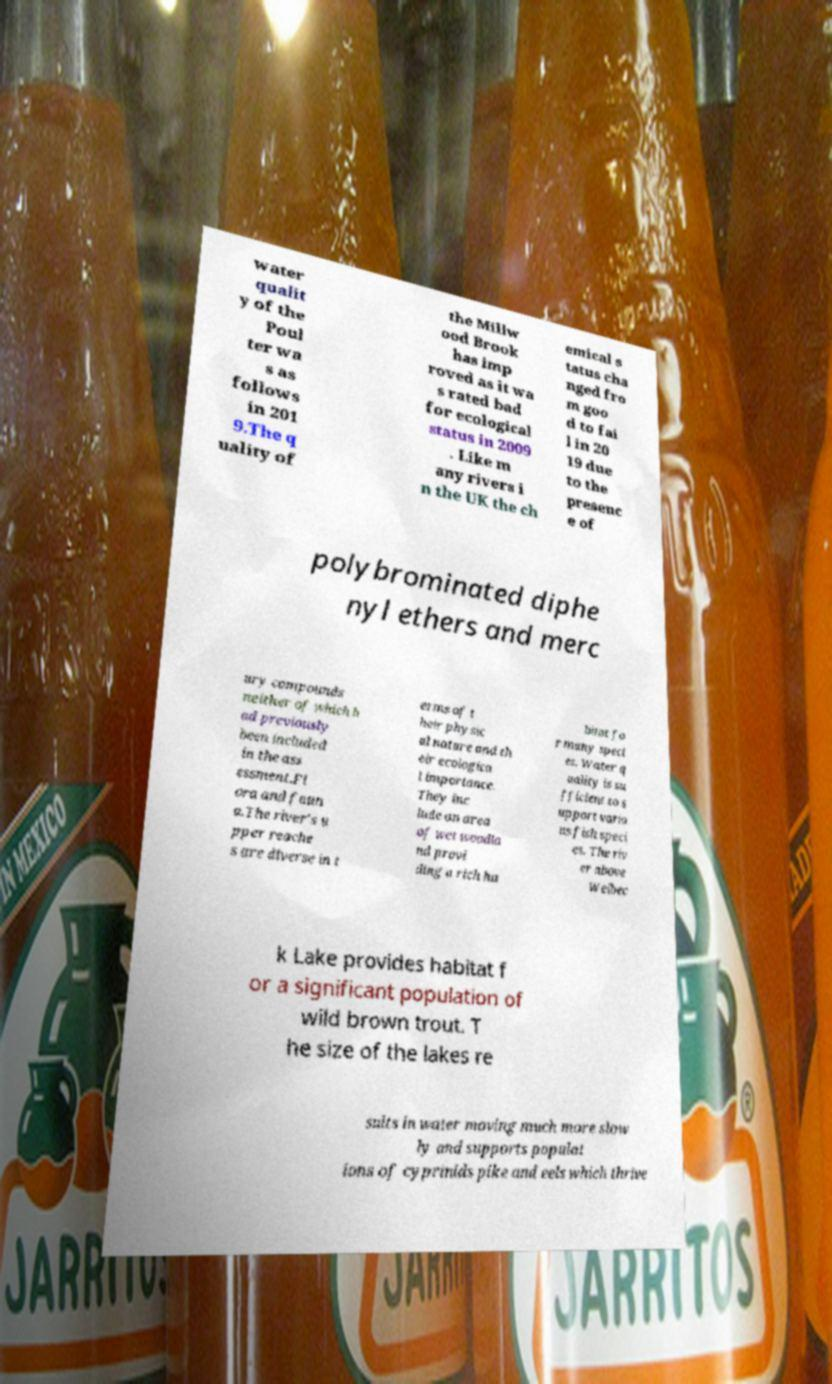Please read and relay the text visible in this image. What does it say? water qualit y of the Poul ter wa s as follows in 201 9.The q uality of the Millw ood Brook has imp roved as it wa s rated bad for ecological status in 2009 . Like m any rivers i n the UK the ch emical s tatus cha nged fro m goo d to fai l in 20 19 due to the presenc e of polybrominated diphe nyl ethers and merc ury compounds neither of which h ad previously been included in the ass essment.Fl ora and faun a.The river's u pper reache s are diverse in t erms of t heir physic al nature and th eir ecologica l importance. They inc lude an area of wet woodla nd provi ding a rich ha bitat fo r many speci es. Water q uality is su fficient to s upport vario us fish speci es. The riv er above Welbec k Lake provides habitat f or a significant population of wild brown trout. T he size of the lakes re sults in water moving much more slow ly and supports populat ions of cyprinids pike and eels which thrive 